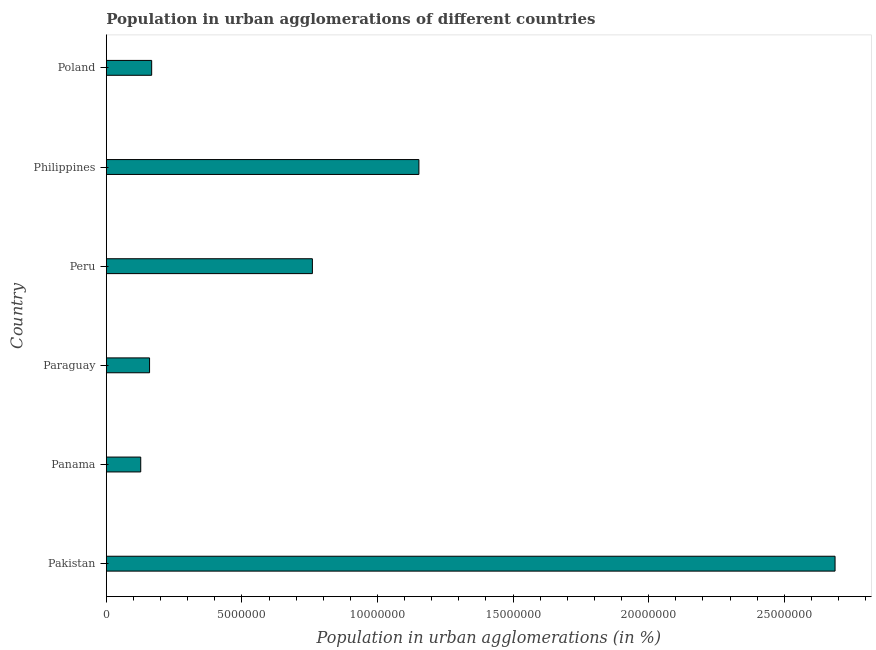Does the graph contain any zero values?
Offer a terse response. No. Does the graph contain grids?
Offer a very short reply. No. What is the title of the graph?
Your answer should be very brief. Population in urban agglomerations of different countries. What is the label or title of the X-axis?
Your answer should be compact. Population in urban agglomerations (in %). What is the label or title of the Y-axis?
Offer a terse response. Country. What is the population in urban agglomerations in Peru?
Your answer should be compact. 7.60e+06. Across all countries, what is the maximum population in urban agglomerations?
Keep it short and to the point. 2.69e+07. Across all countries, what is the minimum population in urban agglomerations?
Your answer should be compact. 1.27e+06. In which country was the population in urban agglomerations maximum?
Provide a succinct answer. Pakistan. In which country was the population in urban agglomerations minimum?
Offer a terse response. Panama. What is the sum of the population in urban agglomerations?
Offer a very short reply. 5.05e+07. What is the difference between the population in urban agglomerations in Philippines and Poland?
Offer a terse response. 9.86e+06. What is the average population in urban agglomerations per country?
Provide a succinct answer. 8.42e+06. What is the median population in urban agglomerations?
Make the answer very short. 4.64e+06. What is the ratio of the population in urban agglomerations in Peru to that in Philippines?
Provide a succinct answer. 0.66. Is the difference between the population in urban agglomerations in Pakistan and Poland greater than the difference between any two countries?
Ensure brevity in your answer.  No. What is the difference between the highest and the second highest population in urban agglomerations?
Keep it short and to the point. 1.53e+07. Is the sum of the population in urban agglomerations in Pakistan and Poland greater than the maximum population in urban agglomerations across all countries?
Offer a very short reply. Yes. What is the difference between the highest and the lowest population in urban agglomerations?
Your response must be concise. 2.56e+07. In how many countries, is the population in urban agglomerations greater than the average population in urban agglomerations taken over all countries?
Ensure brevity in your answer.  2. How many bars are there?
Your answer should be compact. 6. What is the difference between two consecutive major ticks on the X-axis?
Give a very brief answer. 5.00e+06. What is the Population in urban agglomerations (in %) in Pakistan?
Offer a terse response. 2.69e+07. What is the Population in urban agglomerations (in %) in Panama?
Offer a terse response. 1.27e+06. What is the Population in urban agglomerations (in %) in Paraguay?
Keep it short and to the point. 1.59e+06. What is the Population in urban agglomerations (in %) of Peru?
Keep it short and to the point. 7.60e+06. What is the Population in urban agglomerations (in %) in Philippines?
Your response must be concise. 1.15e+07. What is the Population in urban agglomerations (in %) of Poland?
Make the answer very short. 1.67e+06. What is the difference between the Population in urban agglomerations (in %) in Pakistan and Panama?
Keep it short and to the point. 2.56e+07. What is the difference between the Population in urban agglomerations (in %) in Pakistan and Paraguay?
Make the answer very short. 2.53e+07. What is the difference between the Population in urban agglomerations (in %) in Pakistan and Peru?
Ensure brevity in your answer.  1.93e+07. What is the difference between the Population in urban agglomerations (in %) in Pakistan and Philippines?
Give a very brief answer. 1.53e+07. What is the difference between the Population in urban agglomerations (in %) in Pakistan and Poland?
Offer a terse response. 2.52e+07. What is the difference between the Population in urban agglomerations (in %) in Panama and Paraguay?
Give a very brief answer. -3.26e+05. What is the difference between the Population in urban agglomerations (in %) in Panama and Peru?
Provide a short and direct response. -6.33e+06. What is the difference between the Population in urban agglomerations (in %) in Panama and Philippines?
Provide a succinct answer. -1.03e+07. What is the difference between the Population in urban agglomerations (in %) in Panama and Poland?
Offer a very short reply. -4.04e+05. What is the difference between the Population in urban agglomerations (in %) in Paraguay and Peru?
Make the answer very short. -6.00e+06. What is the difference between the Population in urban agglomerations (in %) in Paraguay and Philippines?
Make the answer very short. -9.93e+06. What is the difference between the Population in urban agglomerations (in %) in Paraguay and Poland?
Make the answer very short. -7.79e+04. What is the difference between the Population in urban agglomerations (in %) in Peru and Philippines?
Keep it short and to the point. -3.93e+06. What is the difference between the Population in urban agglomerations (in %) in Peru and Poland?
Ensure brevity in your answer.  5.93e+06. What is the difference between the Population in urban agglomerations (in %) in Philippines and Poland?
Offer a very short reply. 9.86e+06. What is the ratio of the Population in urban agglomerations (in %) in Pakistan to that in Panama?
Your response must be concise. 21.18. What is the ratio of the Population in urban agglomerations (in %) in Pakistan to that in Paraguay?
Keep it short and to the point. 16.86. What is the ratio of the Population in urban agglomerations (in %) in Pakistan to that in Peru?
Your response must be concise. 3.54. What is the ratio of the Population in urban agglomerations (in %) in Pakistan to that in Philippines?
Give a very brief answer. 2.33. What is the ratio of the Population in urban agglomerations (in %) in Pakistan to that in Poland?
Provide a short and direct response. 16.07. What is the ratio of the Population in urban agglomerations (in %) in Panama to that in Paraguay?
Your response must be concise. 0.8. What is the ratio of the Population in urban agglomerations (in %) in Panama to that in Peru?
Your answer should be compact. 0.17. What is the ratio of the Population in urban agglomerations (in %) in Panama to that in Philippines?
Provide a succinct answer. 0.11. What is the ratio of the Population in urban agglomerations (in %) in Panama to that in Poland?
Your answer should be compact. 0.76. What is the ratio of the Population in urban agglomerations (in %) in Paraguay to that in Peru?
Make the answer very short. 0.21. What is the ratio of the Population in urban agglomerations (in %) in Paraguay to that in Philippines?
Keep it short and to the point. 0.14. What is the ratio of the Population in urban agglomerations (in %) in Paraguay to that in Poland?
Give a very brief answer. 0.95. What is the ratio of the Population in urban agglomerations (in %) in Peru to that in Philippines?
Make the answer very short. 0.66. What is the ratio of the Population in urban agglomerations (in %) in Peru to that in Poland?
Keep it short and to the point. 4.54. What is the ratio of the Population in urban agglomerations (in %) in Philippines to that in Poland?
Provide a succinct answer. 6.89. 